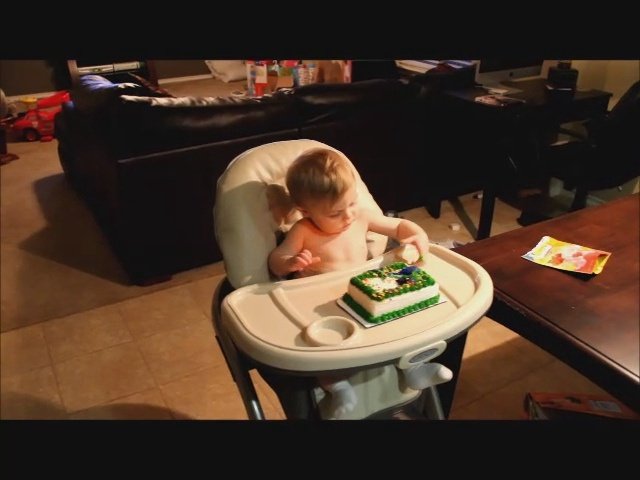Describe the objects in this image and their specific colors. I can see couch in black, maroon, and gray tones, dining table in black, maroon, brown, and gray tones, chair in black, gray, and maroon tones, people in black, maroon, brown, and tan tones, and chair in black and maroon tones in this image. 